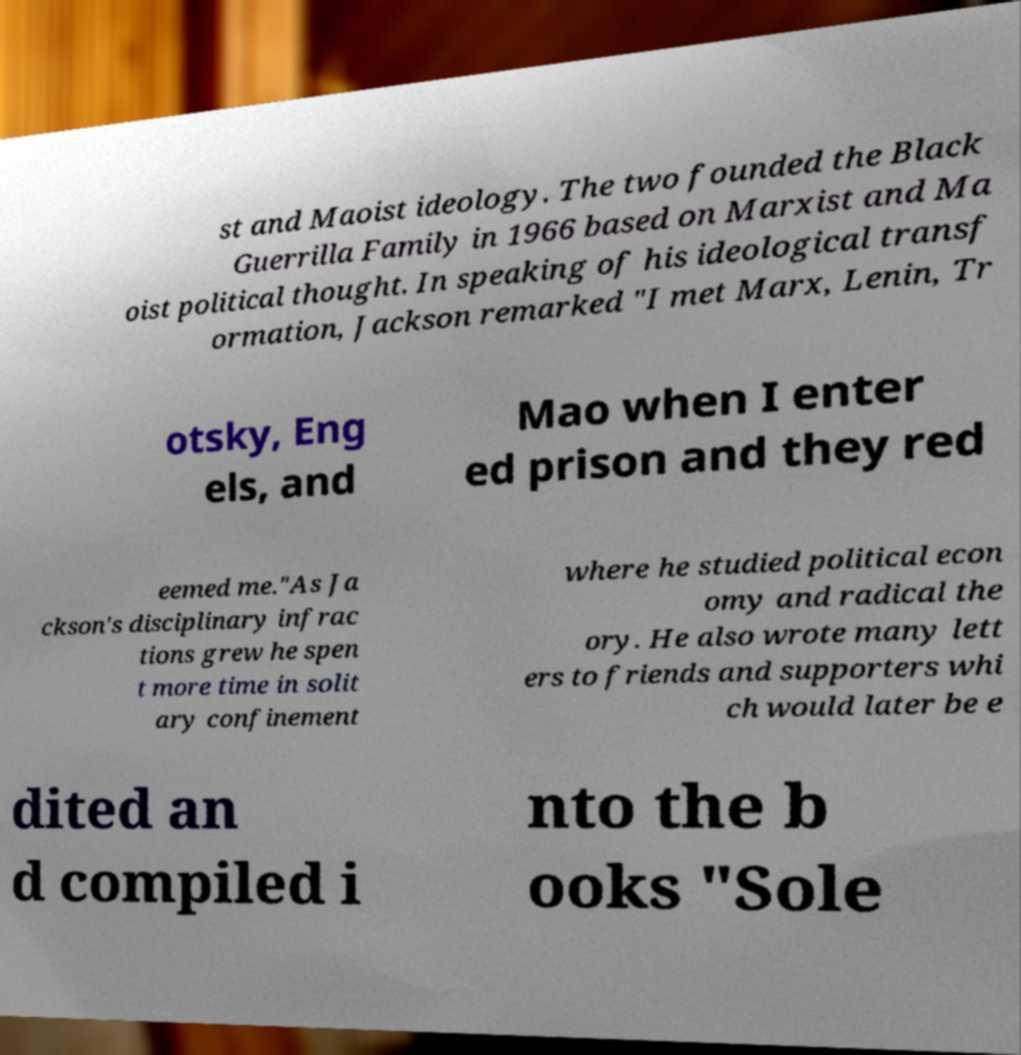For documentation purposes, I need the text within this image transcribed. Could you provide that? st and Maoist ideology. The two founded the Black Guerrilla Family in 1966 based on Marxist and Ma oist political thought. In speaking of his ideological transf ormation, Jackson remarked "I met Marx, Lenin, Tr otsky, Eng els, and Mao when I enter ed prison and they red eemed me."As Ja ckson's disciplinary infrac tions grew he spen t more time in solit ary confinement where he studied political econ omy and radical the ory. He also wrote many lett ers to friends and supporters whi ch would later be e dited an d compiled i nto the b ooks "Sole 